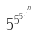<formula> <loc_0><loc_0><loc_500><loc_500>5 ^ { 5 ^ { 5 ^ { . ^ { . ^ { n } } } } }</formula> 